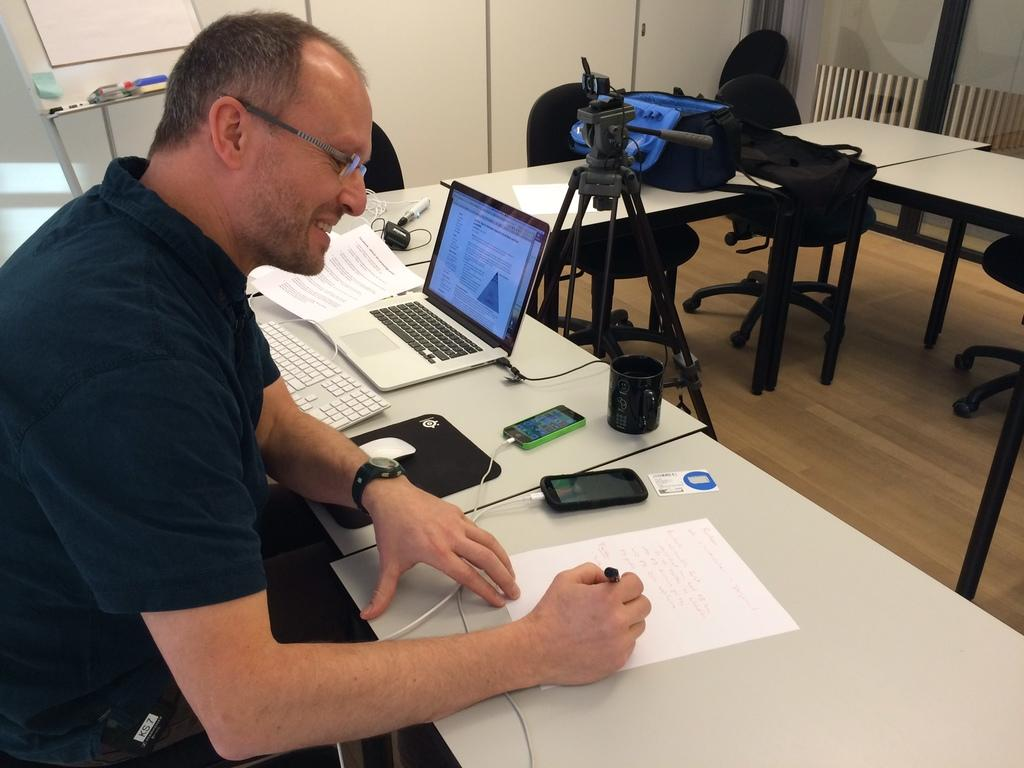What is the person at the table doing in the image? The facts do not specify what the person is doing, but we can see that they are sitting at the table. What electronic devices are on the table? There is a laptop and a mobile phone on the table. What stationery items are on the table? There is a paper and a pen on the table. What equipment is on the table for photography purposes? There is a camera stand on the table. What type of furniture is present in the image? There are chairs, tables, and cupboards in the image. How many rabbits are hopping around on the table in the image? There are no rabbits present in the image. What type of stone is used to build the cupboards in the image? The facts do not mention the material used to build the cupboards, and there are no stones visible in the image. 